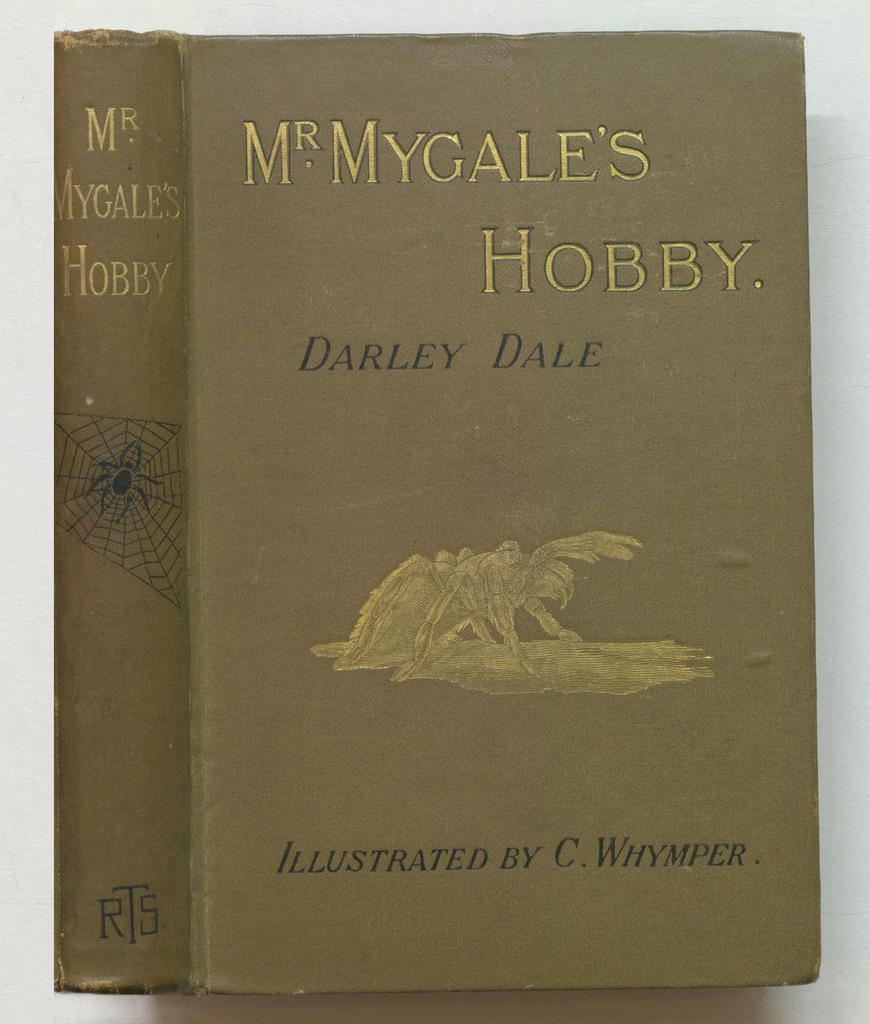<image>
Write a terse but informative summary of the picture. A book by Darley Dale is in an olive green color. 